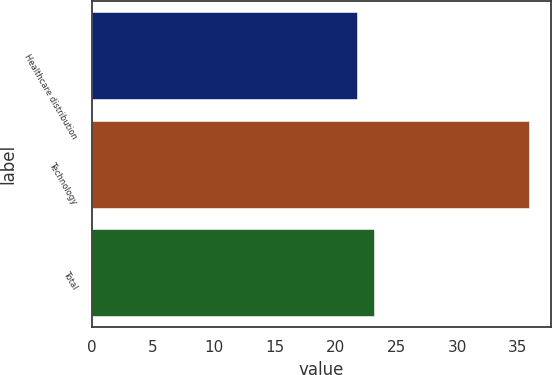Convert chart to OTSL. <chart><loc_0><loc_0><loc_500><loc_500><bar_chart><fcel>Healthcare distribution<fcel>Technology<fcel>Total<nl><fcel>21.8<fcel>35.9<fcel>23.21<nl></chart> 